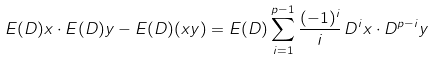Convert formula to latex. <formula><loc_0><loc_0><loc_500><loc_500>E ( D ) x \cdot E ( D ) y - E ( D ) ( x y ) = E ( D ) \sum _ { i = 1 } ^ { p - 1 } \frac { ( - 1 ) ^ { i } } { i } \, D ^ { i } x \cdot D ^ { p - i } y</formula> 